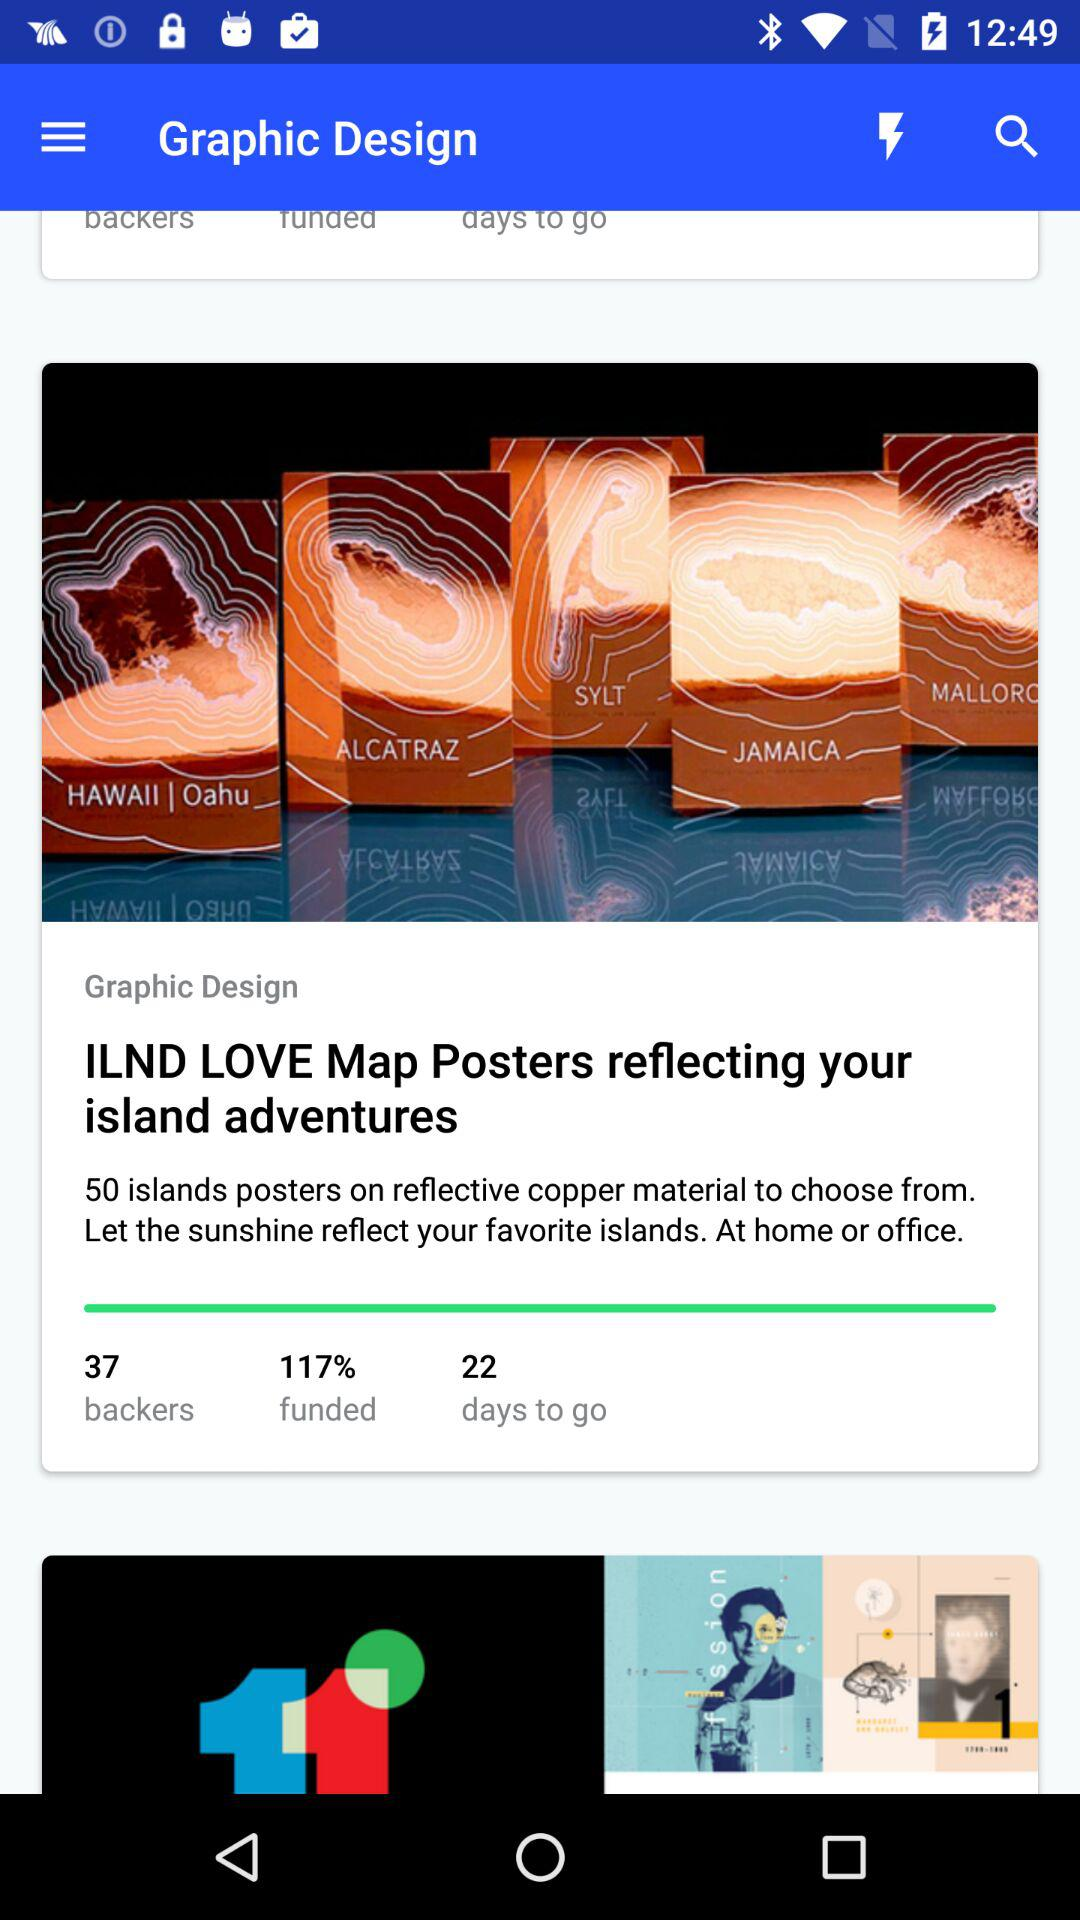What percentage of funds is given on the screen? The percentage of funds given on the screen is 117. 